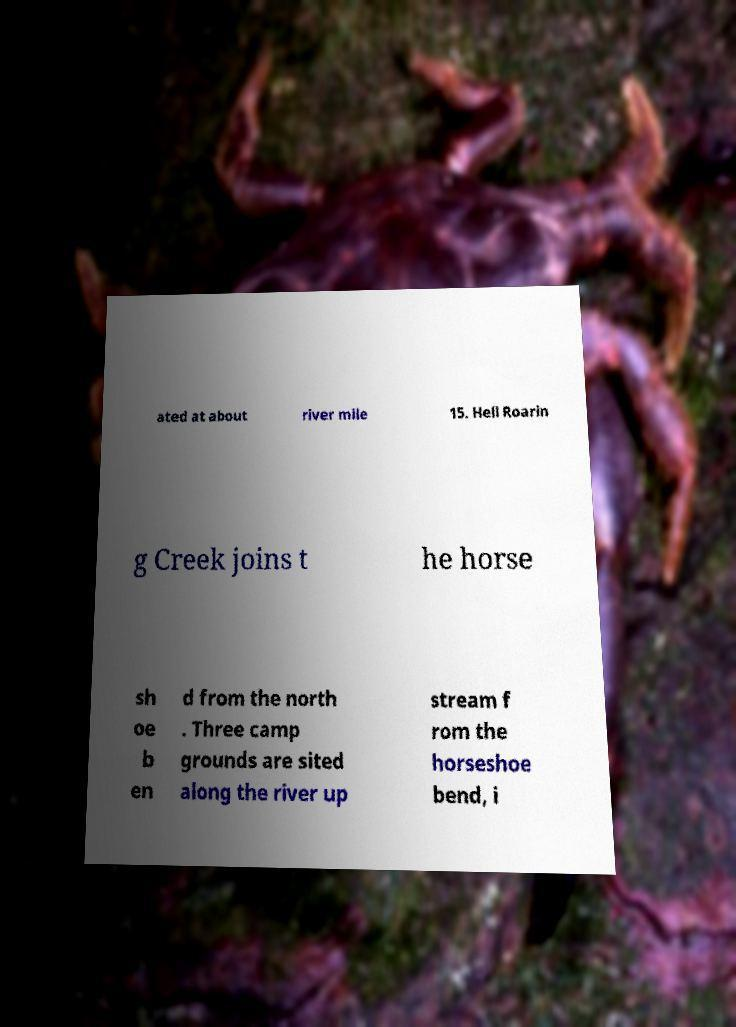Please read and relay the text visible in this image. What does it say? ated at about river mile 15. Hell Roarin g Creek joins t he horse sh oe b en d from the north . Three camp grounds are sited along the river up stream f rom the horseshoe bend, i 